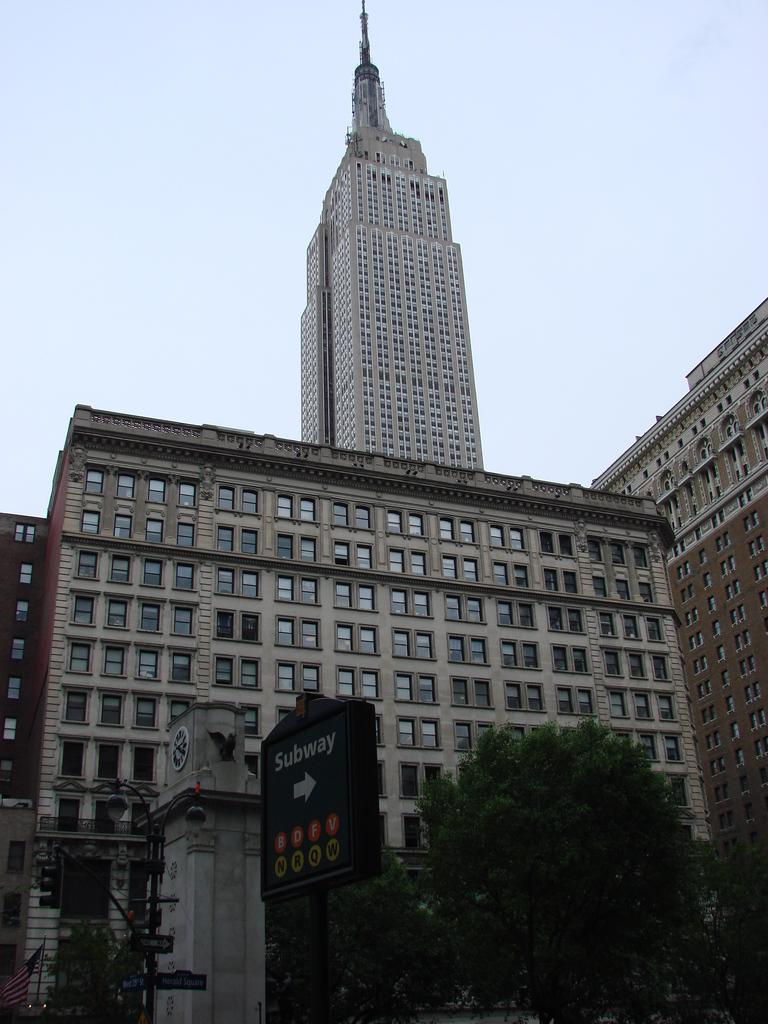What type of natural elements can be seen in the image? There are trees in the image. What is the color of the board in the image? The board in the image is black. What is attached to the pole in the image? There are boards attached to the pole in the image. What is the flag attached to in the image? The flag is attached to a pole in the image. What can be seen in the background of the image? Buildings and the sky are visible in the background of the image. How many shoes are visible in the image? There are no shoes present in the image. What do people believe about the flag in the image? The image does not provide any information about people's beliefs regarding the flag. 